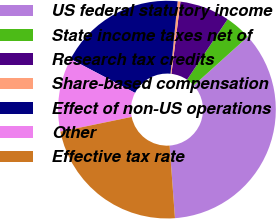<chart> <loc_0><loc_0><loc_500><loc_500><pie_chart><fcel>US federal statutory income<fcel>State income taxes net of<fcel>Research tax credits<fcel>Share-based compensation<fcel>Effect of non-US operations<fcel>Other<fcel>Effective tax rate<nl><fcel>35.51%<fcel>3.92%<fcel>7.43%<fcel>0.41%<fcel>18.87%<fcel>10.94%<fcel>22.93%<nl></chart> 